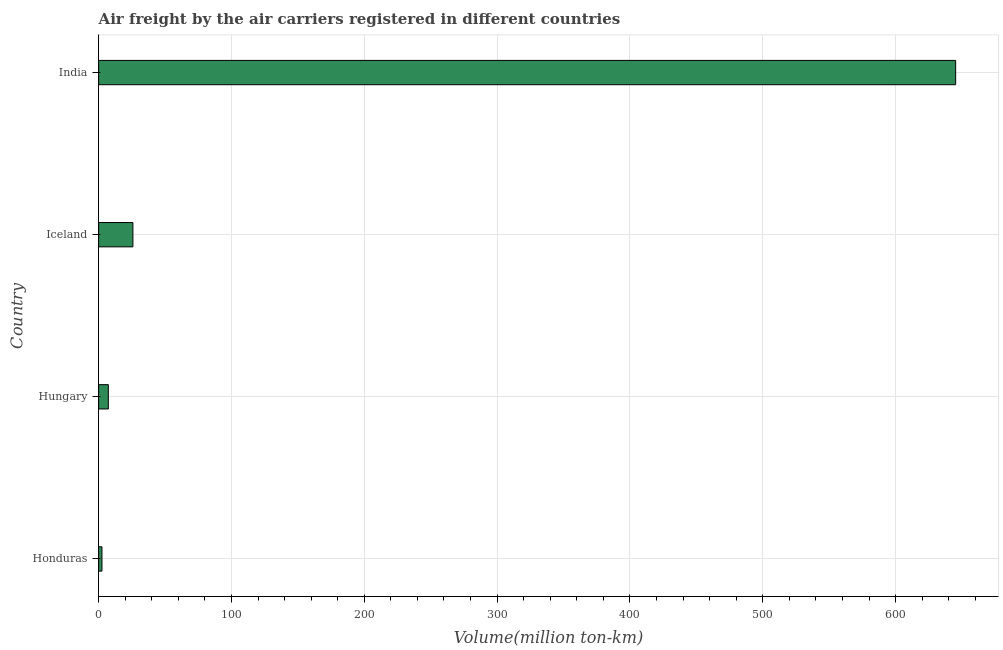Does the graph contain grids?
Ensure brevity in your answer.  Yes. What is the title of the graph?
Make the answer very short. Air freight by the air carriers registered in different countries. What is the label or title of the X-axis?
Ensure brevity in your answer.  Volume(million ton-km). What is the label or title of the Y-axis?
Your answer should be compact. Country. What is the air freight in Honduras?
Keep it short and to the point. 2.5. Across all countries, what is the maximum air freight?
Keep it short and to the point. 645.2. In which country was the air freight maximum?
Your response must be concise. India. In which country was the air freight minimum?
Your response must be concise. Honduras. What is the sum of the air freight?
Provide a succinct answer. 680.8. What is the difference between the air freight in Honduras and Iceland?
Your answer should be compact. -23.3. What is the average air freight per country?
Offer a terse response. 170.2. What is the median air freight?
Offer a terse response. 16.55. What is the ratio of the air freight in Honduras to that in India?
Your answer should be compact. 0. Is the air freight in Hungary less than that in Iceland?
Offer a very short reply. Yes. Is the difference between the air freight in Honduras and Iceland greater than the difference between any two countries?
Provide a succinct answer. No. What is the difference between the highest and the second highest air freight?
Provide a short and direct response. 619.4. What is the difference between the highest and the lowest air freight?
Give a very brief answer. 642.7. How many bars are there?
Offer a very short reply. 4. How many countries are there in the graph?
Make the answer very short. 4. Are the values on the major ticks of X-axis written in scientific E-notation?
Your answer should be compact. No. What is the Volume(million ton-km) in Hungary?
Provide a succinct answer. 7.3. What is the Volume(million ton-km) of Iceland?
Make the answer very short. 25.8. What is the Volume(million ton-km) in India?
Provide a short and direct response. 645.2. What is the difference between the Volume(million ton-km) in Honduras and Iceland?
Make the answer very short. -23.3. What is the difference between the Volume(million ton-km) in Honduras and India?
Offer a terse response. -642.7. What is the difference between the Volume(million ton-km) in Hungary and Iceland?
Make the answer very short. -18.5. What is the difference between the Volume(million ton-km) in Hungary and India?
Ensure brevity in your answer.  -637.9. What is the difference between the Volume(million ton-km) in Iceland and India?
Give a very brief answer. -619.4. What is the ratio of the Volume(million ton-km) in Honduras to that in Hungary?
Keep it short and to the point. 0.34. What is the ratio of the Volume(million ton-km) in Honduras to that in Iceland?
Offer a terse response. 0.1. What is the ratio of the Volume(million ton-km) in Honduras to that in India?
Your response must be concise. 0. What is the ratio of the Volume(million ton-km) in Hungary to that in Iceland?
Provide a short and direct response. 0.28. What is the ratio of the Volume(million ton-km) in Hungary to that in India?
Offer a very short reply. 0.01. What is the ratio of the Volume(million ton-km) in Iceland to that in India?
Provide a succinct answer. 0.04. 